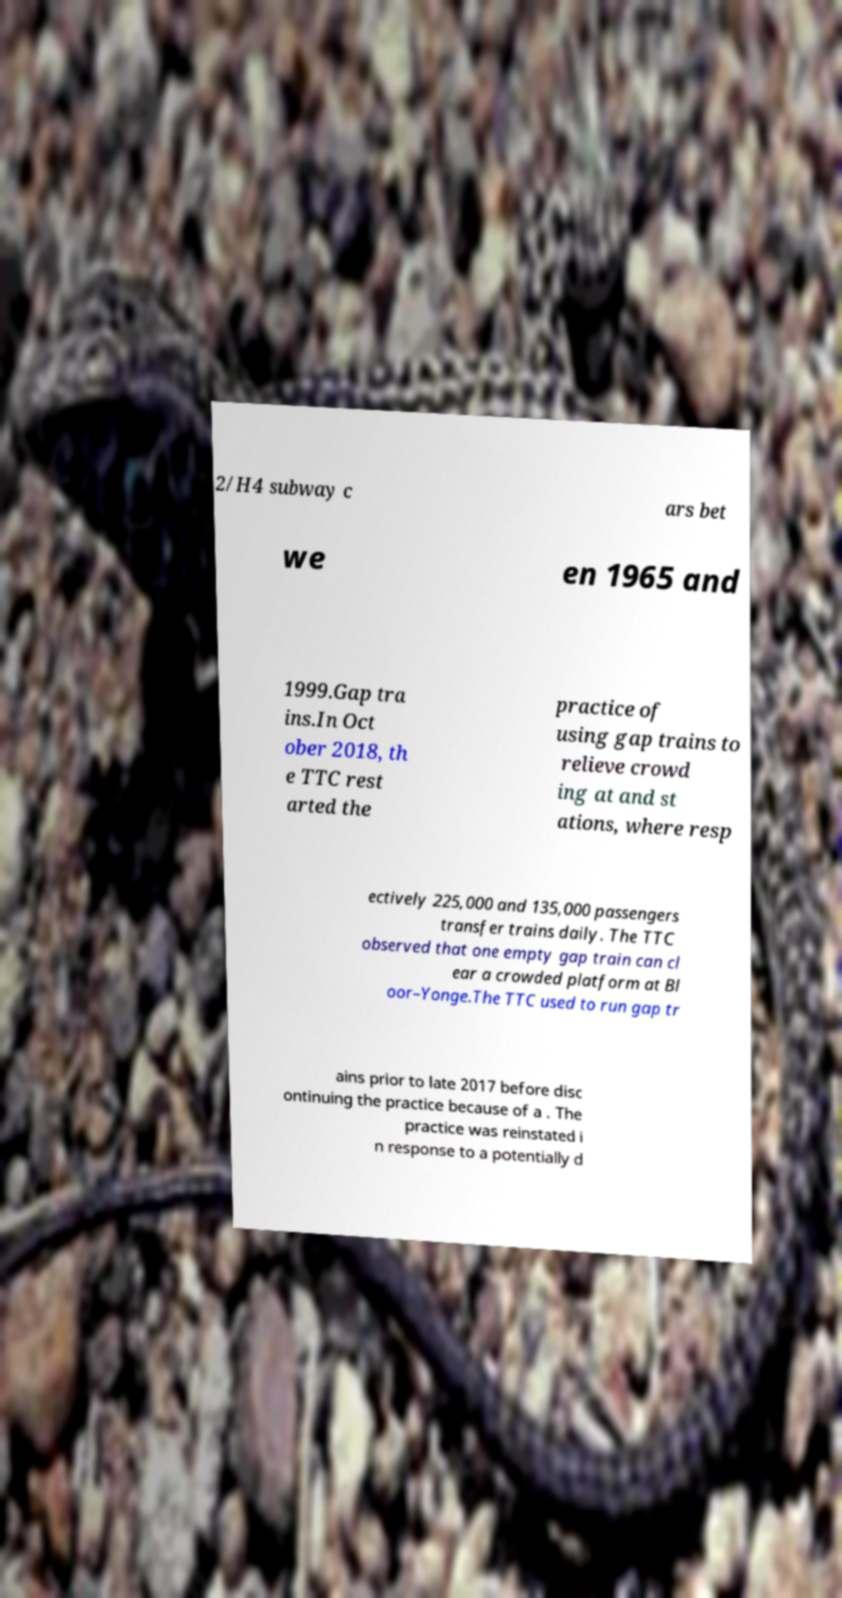Could you assist in decoding the text presented in this image and type it out clearly? 2/H4 subway c ars bet we en 1965 and 1999.Gap tra ins.In Oct ober 2018, th e TTC rest arted the practice of using gap trains to relieve crowd ing at and st ations, where resp ectively 225,000 and 135,000 passengers transfer trains daily. The TTC observed that one empty gap train can cl ear a crowded platform at Bl oor–Yonge.The TTC used to run gap tr ains prior to late 2017 before disc ontinuing the practice because of a . The practice was reinstated i n response to a potentially d 